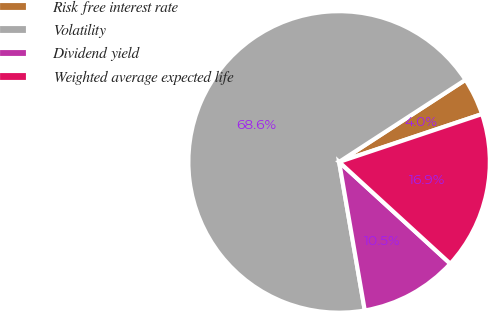<chart> <loc_0><loc_0><loc_500><loc_500><pie_chart><fcel>Risk free interest rate<fcel>Volatility<fcel>Dividend yield<fcel>Weighted average expected life<nl><fcel>4.03%<fcel>68.55%<fcel>10.48%<fcel>16.94%<nl></chart> 